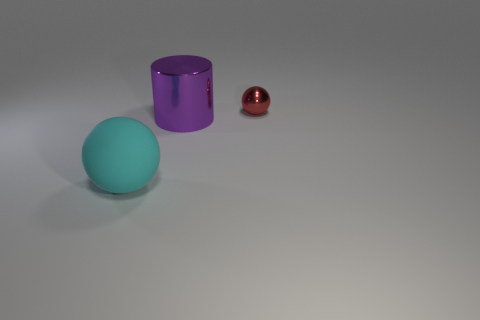Add 2 cyan rubber things. How many objects exist? 5 Subtract all spheres. How many objects are left? 1 Subtract all tiny red spheres. Subtract all big brown blocks. How many objects are left? 2 Add 1 big purple things. How many big purple things are left? 2 Add 2 tiny cyan metallic cubes. How many tiny cyan metallic cubes exist? 2 Subtract 0 cyan cubes. How many objects are left? 3 